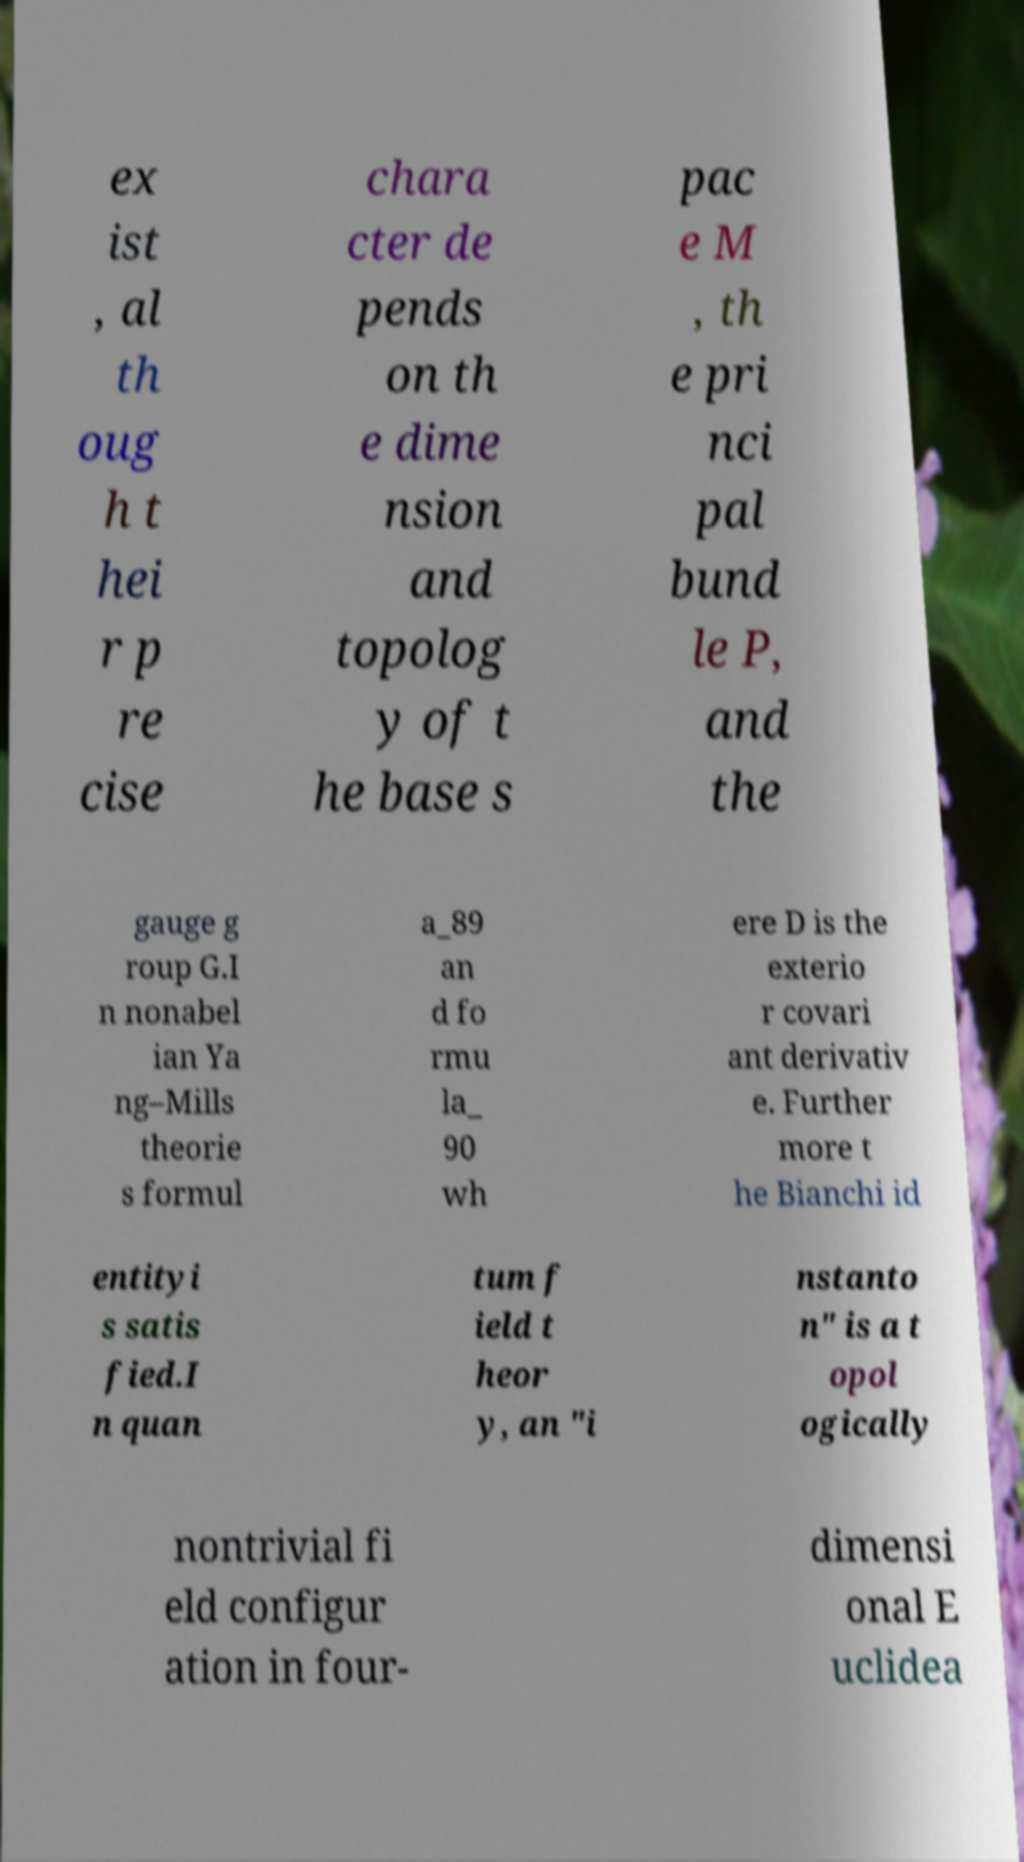Can you accurately transcribe the text from the provided image for me? ex ist , al th oug h t hei r p re cise chara cter de pends on th e dime nsion and topolog y of t he base s pac e M , th e pri nci pal bund le P, and the gauge g roup G.I n nonabel ian Ya ng–Mills theorie s formul a_89 an d fo rmu la_ 90 wh ere D is the exterio r covari ant derivativ e. Further more t he Bianchi id entityi s satis fied.I n quan tum f ield t heor y, an "i nstanto n" is a t opol ogically nontrivial fi eld configur ation in four- dimensi onal E uclidea 